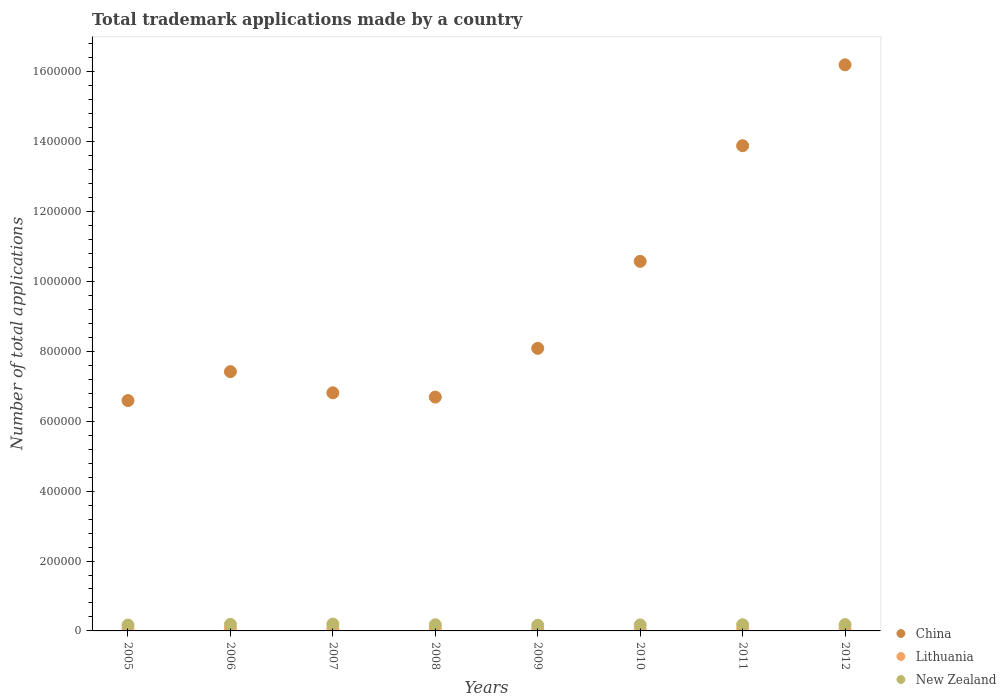How many different coloured dotlines are there?
Keep it short and to the point. 3. Is the number of dotlines equal to the number of legend labels?
Offer a very short reply. Yes. What is the number of applications made by in China in 2009?
Provide a succinct answer. 8.09e+05. Across all years, what is the maximum number of applications made by in New Zealand?
Give a very brief answer. 1.96e+04. Across all years, what is the minimum number of applications made by in New Zealand?
Offer a very short reply. 1.62e+04. In which year was the number of applications made by in Lithuania maximum?
Offer a terse response. 2007. In which year was the number of applications made by in China minimum?
Offer a terse response. 2005. What is the total number of applications made by in China in the graph?
Give a very brief answer. 7.63e+06. What is the difference between the number of applications made by in New Zealand in 2011 and that in 2012?
Give a very brief answer. -279. What is the difference between the number of applications made by in Lithuania in 2006 and the number of applications made by in China in 2010?
Your response must be concise. -1.05e+06. What is the average number of applications made by in China per year?
Your answer should be very brief. 9.53e+05. In the year 2006, what is the difference between the number of applications made by in China and number of applications made by in New Zealand?
Offer a terse response. 7.23e+05. In how many years, is the number of applications made by in Lithuania greater than 280000?
Give a very brief answer. 0. What is the ratio of the number of applications made by in China in 2005 to that in 2007?
Provide a succinct answer. 0.97. Is the difference between the number of applications made by in China in 2006 and 2007 greater than the difference between the number of applications made by in New Zealand in 2006 and 2007?
Your answer should be compact. Yes. What is the difference between the highest and the second highest number of applications made by in New Zealand?
Ensure brevity in your answer.  784. What is the difference between the highest and the lowest number of applications made by in New Zealand?
Ensure brevity in your answer.  3420. Is the sum of the number of applications made by in China in 2009 and 2010 greater than the maximum number of applications made by in Lithuania across all years?
Ensure brevity in your answer.  Yes. Is it the case that in every year, the sum of the number of applications made by in New Zealand and number of applications made by in Lithuania  is greater than the number of applications made by in China?
Offer a very short reply. No. What is the difference between two consecutive major ticks on the Y-axis?
Your answer should be compact. 2.00e+05. Are the values on the major ticks of Y-axis written in scientific E-notation?
Provide a succinct answer. No. Does the graph contain any zero values?
Your response must be concise. No. How are the legend labels stacked?
Provide a succinct answer. Vertical. What is the title of the graph?
Provide a short and direct response. Total trademark applications made by a country. Does "Tunisia" appear as one of the legend labels in the graph?
Offer a very short reply. No. What is the label or title of the Y-axis?
Provide a succinct answer. Number of total applications. What is the Number of total applications of China in 2005?
Your answer should be compact. 6.59e+05. What is the Number of total applications in Lithuania in 2005?
Provide a short and direct response. 6302. What is the Number of total applications of New Zealand in 2005?
Offer a terse response. 1.68e+04. What is the Number of total applications of China in 2006?
Provide a short and direct response. 7.42e+05. What is the Number of total applications of Lithuania in 2006?
Offer a very short reply. 6369. What is the Number of total applications in New Zealand in 2006?
Ensure brevity in your answer.  1.88e+04. What is the Number of total applications in China in 2007?
Ensure brevity in your answer.  6.81e+05. What is the Number of total applications in Lithuania in 2007?
Your answer should be very brief. 6440. What is the Number of total applications in New Zealand in 2007?
Offer a very short reply. 1.96e+04. What is the Number of total applications of China in 2008?
Your answer should be very brief. 6.69e+05. What is the Number of total applications in Lithuania in 2008?
Your response must be concise. 6332. What is the Number of total applications in New Zealand in 2008?
Make the answer very short. 1.76e+04. What is the Number of total applications of China in 2009?
Your answer should be very brief. 8.09e+05. What is the Number of total applications of Lithuania in 2009?
Keep it short and to the point. 4465. What is the Number of total applications of New Zealand in 2009?
Ensure brevity in your answer.  1.62e+04. What is the Number of total applications of China in 2010?
Your answer should be compact. 1.06e+06. What is the Number of total applications of Lithuania in 2010?
Your response must be concise. 4274. What is the Number of total applications in New Zealand in 2010?
Your answer should be compact. 1.71e+04. What is the Number of total applications in China in 2011?
Provide a short and direct response. 1.39e+06. What is the Number of total applications of Lithuania in 2011?
Give a very brief answer. 4315. What is the Number of total applications of New Zealand in 2011?
Ensure brevity in your answer.  1.77e+04. What is the Number of total applications of China in 2012?
Provide a short and direct response. 1.62e+06. What is the Number of total applications in Lithuania in 2012?
Your response must be concise. 4222. What is the Number of total applications of New Zealand in 2012?
Your response must be concise. 1.80e+04. Across all years, what is the maximum Number of total applications of China?
Offer a terse response. 1.62e+06. Across all years, what is the maximum Number of total applications of Lithuania?
Offer a terse response. 6440. Across all years, what is the maximum Number of total applications in New Zealand?
Keep it short and to the point. 1.96e+04. Across all years, what is the minimum Number of total applications of China?
Ensure brevity in your answer.  6.59e+05. Across all years, what is the minimum Number of total applications of Lithuania?
Your answer should be very brief. 4222. Across all years, what is the minimum Number of total applications in New Zealand?
Provide a short and direct response. 1.62e+04. What is the total Number of total applications in China in the graph?
Ensure brevity in your answer.  7.63e+06. What is the total Number of total applications of Lithuania in the graph?
Your response must be concise. 4.27e+04. What is the total Number of total applications of New Zealand in the graph?
Ensure brevity in your answer.  1.42e+05. What is the difference between the Number of total applications of China in 2005 and that in 2006?
Give a very brief answer. -8.28e+04. What is the difference between the Number of total applications of Lithuania in 2005 and that in 2006?
Your answer should be very brief. -67. What is the difference between the Number of total applications of New Zealand in 2005 and that in 2006?
Your answer should be very brief. -1993. What is the difference between the Number of total applications of China in 2005 and that in 2007?
Provide a succinct answer. -2.22e+04. What is the difference between the Number of total applications in Lithuania in 2005 and that in 2007?
Your response must be concise. -138. What is the difference between the Number of total applications in New Zealand in 2005 and that in 2007?
Your response must be concise. -2777. What is the difference between the Number of total applications of China in 2005 and that in 2008?
Offer a terse response. -9940. What is the difference between the Number of total applications of Lithuania in 2005 and that in 2008?
Make the answer very short. -30. What is the difference between the Number of total applications in New Zealand in 2005 and that in 2008?
Ensure brevity in your answer.  -749. What is the difference between the Number of total applications of China in 2005 and that in 2009?
Give a very brief answer. -1.49e+05. What is the difference between the Number of total applications of Lithuania in 2005 and that in 2009?
Provide a short and direct response. 1837. What is the difference between the Number of total applications of New Zealand in 2005 and that in 2009?
Make the answer very short. 643. What is the difference between the Number of total applications of China in 2005 and that in 2010?
Give a very brief answer. -3.98e+05. What is the difference between the Number of total applications in Lithuania in 2005 and that in 2010?
Your answer should be very brief. 2028. What is the difference between the Number of total applications of New Zealand in 2005 and that in 2010?
Ensure brevity in your answer.  -291. What is the difference between the Number of total applications of China in 2005 and that in 2011?
Give a very brief answer. -7.29e+05. What is the difference between the Number of total applications of Lithuania in 2005 and that in 2011?
Your answer should be very brief. 1987. What is the difference between the Number of total applications in New Zealand in 2005 and that in 2011?
Your answer should be very brief. -915. What is the difference between the Number of total applications in China in 2005 and that in 2012?
Keep it short and to the point. -9.61e+05. What is the difference between the Number of total applications in Lithuania in 2005 and that in 2012?
Your answer should be compact. 2080. What is the difference between the Number of total applications of New Zealand in 2005 and that in 2012?
Make the answer very short. -1194. What is the difference between the Number of total applications of China in 2006 and that in 2007?
Your answer should be compact. 6.06e+04. What is the difference between the Number of total applications in Lithuania in 2006 and that in 2007?
Your answer should be very brief. -71. What is the difference between the Number of total applications in New Zealand in 2006 and that in 2007?
Provide a short and direct response. -784. What is the difference between the Number of total applications in China in 2006 and that in 2008?
Offer a very short reply. 7.29e+04. What is the difference between the Number of total applications in Lithuania in 2006 and that in 2008?
Provide a short and direct response. 37. What is the difference between the Number of total applications of New Zealand in 2006 and that in 2008?
Give a very brief answer. 1244. What is the difference between the Number of total applications in China in 2006 and that in 2009?
Give a very brief answer. -6.66e+04. What is the difference between the Number of total applications in Lithuania in 2006 and that in 2009?
Keep it short and to the point. 1904. What is the difference between the Number of total applications in New Zealand in 2006 and that in 2009?
Keep it short and to the point. 2636. What is the difference between the Number of total applications in China in 2006 and that in 2010?
Provide a short and direct response. -3.16e+05. What is the difference between the Number of total applications of Lithuania in 2006 and that in 2010?
Your response must be concise. 2095. What is the difference between the Number of total applications in New Zealand in 2006 and that in 2010?
Ensure brevity in your answer.  1702. What is the difference between the Number of total applications in China in 2006 and that in 2011?
Keep it short and to the point. -6.46e+05. What is the difference between the Number of total applications in Lithuania in 2006 and that in 2011?
Give a very brief answer. 2054. What is the difference between the Number of total applications of New Zealand in 2006 and that in 2011?
Ensure brevity in your answer.  1078. What is the difference between the Number of total applications in China in 2006 and that in 2012?
Make the answer very short. -8.78e+05. What is the difference between the Number of total applications in Lithuania in 2006 and that in 2012?
Provide a succinct answer. 2147. What is the difference between the Number of total applications of New Zealand in 2006 and that in 2012?
Offer a very short reply. 799. What is the difference between the Number of total applications in China in 2007 and that in 2008?
Give a very brief answer. 1.23e+04. What is the difference between the Number of total applications of Lithuania in 2007 and that in 2008?
Your response must be concise. 108. What is the difference between the Number of total applications in New Zealand in 2007 and that in 2008?
Provide a succinct answer. 2028. What is the difference between the Number of total applications in China in 2007 and that in 2009?
Your answer should be very brief. -1.27e+05. What is the difference between the Number of total applications in Lithuania in 2007 and that in 2009?
Your response must be concise. 1975. What is the difference between the Number of total applications of New Zealand in 2007 and that in 2009?
Provide a short and direct response. 3420. What is the difference between the Number of total applications of China in 2007 and that in 2010?
Your answer should be compact. -3.76e+05. What is the difference between the Number of total applications of Lithuania in 2007 and that in 2010?
Your answer should be very brief. 2166. What is the difference between the Number of total applications in New Zealand in 2007 and that in 2010?
Your response must be concise. 2486. What is the difference between the Number of total applications in China in 2007 and that in 2011?
Provide a succinct answer. -7.07e+05. What is the difference between the Number of total applications in Lithuania in 2007 and that in 2011?
Your answer should be compact. 2125. What is the difference between the Number of total applications in New Zealand in 2007 and that in 2011?
Make the answer very short. 1862. What is the difference between the Number of total applications in China in 2007 and that in 2012?
Offer a very short reply. -9.39e+05. What is the difference between the Number of total applications in Lithuania in 2007 and that in 2012?
Your answer should be compact. 2218. What is the difference between the Number of total applications in New Zealand in 2007 and that in 2012?
Offer a terse response. 1583. What is the difference between the Number of total applications of China in 2008 and that in 2009?
Make the answer very short. -1.39e+05. What is the difference between the Number of total applications in Lithuania in 2008 and that in 2009?
Your answer should be very brief. 1867. What is the difference between the Number of total applications in New Zealand in 2008 and that in 2009?
Ensure brevity in your answer.  1392. What is the difference between the Number of total applications of China in 2008 and that in 2010?
Offer a terse response. -3.88e+05. What is the difference between the Number of total applications of Lithuania in 2008 and that in 2010?
Offer a very short reply. 2058. What is the difference between the Number of total applications of New Zealand in 2008 and that in 2010?
Provide a succinct answer. 458. What is the difference between the Number of total applications in China in 2008 and that in 2011?
Your answer should be very brief. -7.19e+05. What is the difference between the Number of total applications in Lithuania in 2008 and that in 2011?
Give a very brief answer. 2017. What is the difference between the Number of total applications in New Zealand in 2008 and that in 2011?
Ensure brevity in your answer.  -166. What is the difference between the Number of total applications in China in 2008 and that in 2012?
Give a very brief answer. -9.51e+05. What is the difference between the Number of total applications of Lithuania in 2008 and that in 2012?
Ensure brevity in your answer.  2110. What is the difference between the Number of total applications in New Zealand in 2008 and that in 2012?
Your answer should be very brief. -445. What is the difference between the Number of total applications of China in 2009 and that in 2010?
Your answer should be compact. -2.49e+05. What is the difference between the Number of total applications in Lithuania in 2009 and that in 2010?
Your response must be concise. 191. What is the difference between the Number of total applications in New Zealand in 2009 and that in 2010?
Your answer should be compact. -934. What is the difference between the Number of total applications of China in 2009 and that in 2011?
Your answer should be compact. -5.80e+05. What is the difference between the Number of total applications in Lithuania in 2009 and that in 2011?
Your answer should be very brief. 150. What is the difference between the Number of total applications in New Zealand in 2009 and that in 2011?
Give a very brief answer. -1558. What is the difference between the Number of total applications in China in 2009 and that in 2012?
Make the answer very short. -8.11e+05. What is the difference between the Number of total applications in Lithuania in 2009 and that in 2012?
Offer a terse response. 243. What is the difference between the Number of total applications of New Zealand in 2009 and that in 2012?
Your answer should be very brief. -1837. What is the difference between the Number of total applications in China in 2010 and that in 2011?
Your answer should be very brief. -3.31e+05. What is the difference between the Number of total applications of Lithuania in 2010 and that in 2011?
Your response must be concise. -41. What is the difference between the Number of total applications of New Zealand in 2010 and that in 2011?
Provide a short and direct response. -624. What is the difference between the Number of total applications of China in 2010 and that in 2012?
Your answer should be very brief. -5.62e+05. What is the difference between the Number of total applications in New Zealand in 2010 and that in 2012?
Your answer should be very brief. -903. What is the difference between the Number of total applications in China in 2011 and that in 2012?
Keep it short and to the point. -2.31e+05. What is the difference between the Number of total applications in Lithuania in 2011 and that in 2012?
Make the answer very short. 93. What is the difference between the Number of total applications in New Zealand in 2011 and that in 2012?
Ensure brevity in your answer.  -279. What is the difference between the Number of total applications in China in 2005 and the Number of total applications in Lithuania in 2006?
Your response must be concise. 6.53e+05. What is the difference between the Number of total applications in China in 2005 and the Number of total applications in New Zealand in 2006?
Your answer should be compact. 6.40e+05. What is the difference between the Number of total applications in Lithuania in 2005 and the Number of total applications in New Zealand in 2006?
Offer a terse response. -1.25e+04. What is the difference between the Number of total applications in China in 2005 and the Number of total applications in Lithuania in 2007?
Make the answer very short. 6.53e+05. What is the difference between the Number of total applications in China in 2005 and the Number of total applications in New Zealand in 2007?
Your answer should be compact. 6.40e+05. What is the difference between the Number of total applications in Lithuania in 2005 and the Number of total applications in New Zealand in 2007?
Give a very brief answer. -1.33e+04. What is the difference between the Number of total applications of China in 2005 and the Number of total applications of Lithuania in 2008?
Provide a succinct answer. 6.53e+05. What is the difference between the Number of total applications of China in 2005 and the Number of total applications of New Zealand in 2008?
Offer a terse response. 6.42e+05. What is the difference between the Number of total applications of Lithuania in 2005 and the Number of total applications of New Zealand in 2008?
Provide a succinct answer. -1.13e+04. What is the difference between the Number of total applications of China in 2005 and the Number of total applications of Lithuania in 2009?
Make the answer very short. 6.55e+05. What is the difference between the Number of total applications of China in 2005 and the Number of total applications of New Zealand in 2009?
Your answer should be compact. 6.43e+05. What is the difference between the Number of total applications of Lithuania in 2005 and the Number of total applications of New Zealand in 2009?
Your answer should be very brief. -9888. What is the difference between the Number of total applications in China in 2005 and the Number of total applications in Lithuania in 2010?
Keep it short and to the point. 6.55e+05. What is the difference between the Number of total applications of China in 2005 and the Number of total applications of New Zealand in 2010?
Ensure brevity in your answer.  6.42e+05. What is the difference between the Number of total applications in Lithuania in 2005 and the Number of total applications in New Zealand in 2010?
Your response must be concise. -1.08e+04. What is the difference between the Number of total applications of China in 2005 and the Number of total applications of Lithuania in 2011?
Provide a short and direct response. 6.55e+05. What is the difference between the Number of total applications in China in 2005 and the Number of total applications in New Zealand in 2011?
Give a very brief answer. 6.41e+05. What is the difference between the Number of total applications in Lithuania in 2005 and the Number of total applications in New Zealand in 2011?
Provide a succinct answer. -1.14e+04. What is the difference between the Number of total applications in China in 2005 and the Number of total applications in Lithuania in 2012?
Offer a terse response. 6.55e+05. What is the difference between the Number of total applications in China in 2005 and the Number of total applications in New Zealand in 2012?
Your answer should be very brief. 6.41e+05. What is the difference between the Number of total applications in Lithuania in 2005 and the Number of total applications in New Zealand in 2012?
Your answer should be compact. -1.17e+04. What is the difference between the Number of total applications of China in 2006 and the Number of total applications of Lithuania in 2007?
Make the answer very short. 7.36e+05. What is the difference between the Number of total applications in China in 2006 and the Number of total applications in New Zealand in 2007?
Make the answer very short. 7.22e+05. What is the difference between the Number of total applications of Lithuania in 2006 and the Number of total applications of New Zealand in 2007?
Your response must be concise. -1.32e+04. What is the difference between the Number of total applications of China in 2006 and the Number of total applications of Lithuania in 2008?
Provide a succinct answer. 7.36e+05. What is the difference between the Number of total applications in China in 2006 and the Number of total applications in New Zealand in 2008?
Keep it short and to the point. 7.24e+05. What is the difference between the Number of total applications of Lithuania in 2006 and the Number of total applications of New Zealand in 2008?
Ensure brevity in your answer.  -1.12e+04. What is the difference between the Number of total applications of China in 2006 and the Number of total applications of Lithuania in 2009?
Provide a short and direct response. 7.37e+05. What is the difference between the Number of total applications in China in 2006 and the Number of total applications in New Zealand in 2009?
Keep it short and to the point. 7.26e+05. What is the difference between the Number of total applications in Lithuania in 2006 and the Number of total applications in New Zealand in 2009?
Offer a very short reply. -9821. What is the difference between the Number of total applications of China in 2006 and the Number of total applications of Lithuania in 2010?
Make the answer very short. 7.38e+05. What is the difference between the Number of total applications in China in 2006 and the Number of total applications in New Zealand in 2010?
Offer a very short reply. 7.25e+05. What is the difference between the Number of total applications of Lithuania in 2006 and the Number of total applications of New Zealand in 2010?
Offer a terse response. -1.08e+04. What is the difference between the Number of total applications of China in 2006 and the Number of total applications of Lithuania in 2011?
Offer a very short reply. 7.38e+05. What is the difference between the Number of total applications of China in 2006 and the Number of total applications of New Zealand in 2011?
Your answer should be very brief. 7.24e+05. What is the difference between the Number of total applications in Lithuania in 2006 and the Number of total applications in New Zealand in 2011?
Offer a terse response. -1.14e+04. What is the difference between the Number of total applications in China in 2006 and the Number of total applications in Lithuania in 2012?
Your response must be concise. 7.38e+05. What is the difference between the Number of total applications in China in 2006 and the Number of total applications in New Zealand in 2012?
Your answer should be compact. 7.24e+05. What is the difference between the Number of total applications of Lithuania in 2006 and the Number of total applications of New Zealand in 2012?
Your answer should be very brief. -1.17e+04. What is the difference between the Number of total applications of China in 2007 and the Number of total applications of Lithuania in 2008?
Offer a terse response. 6.75e+05. What is the difference between the Number of total applications in China in 2007 and the Number of total applications in New Zealand in 2008?
Keep it short and to the point. 6.64e+05. What is the difference between the Number of total applications in Lithuania in 2007 and the Number of total applications in New Zealand in 2008?
Offer a very short reply. -1.11e+04. What is the difference between the Number of total applications of China in 2007 and the Number of total applications of Lithuania in 2009?
Keep it short and to the point. 6.77e+05. What is the difference between the Number of total applications in China in 2007 and the Number of total applications in New Zealand in 2009?
Make the answer very short. 6.65e+05. What is the difference between the Number of total applications of Lithuania in 2007 and the Number of total applications of New Zealand in 2009?
Your answer should be very brief. -9750. What is the difference between the Number of total applications of China in 2007 and the Number of total applications of Lithuania in 2010?
Your answer should be compact. 6.77e+05. What is the difference between the Number of total applications of China in 2007 and the Number of total applications of New Zealand in 2010?
Ensure brevity in your answer.  6.64e+05. What is the difference between the Number of total applications of Lithuania in 2007 and the Number of total applications of New Zealand in 2010?
Provide a short and direct response. -1.07e+04. What is the difference between the Number of total applications of China in 2007 and the Number of total applications of Lithuania in 2011?
Your response must be concise. 6.77e+05. What is the difference between the Number of total applications of China in 2007 and the Number of total applications of New Zealand in 2011?
Your answer should be very brief. 6.64e+05. What is the difference between the Number of total applications of Lithuania in 2007 and the Number of total applications of New Zealand in 2011?
Keep it short and to the point. -1.13e+04. What is the difference between the Number of total applications of China in 2007 and the Number of total applications of Lithuania in 2012?
Your answer should be very brief. 6.77e+05. What is the difference between the Number of total applications of China in 2007 and the Number of total applications of New Zealand in 2012?
Your response must be concise. 6.63e+05. What is the difference between the Number of total applications in Lithuania in 2007 and the Number of total applications in New Zealand in 2012?
Give a very brief answer. -1.16e+04. What is the difference between the Number of total applications of China in 2008 and the Number of total applications of Lithuania in 2009?
Keep it short and to the point. 6.65e+05. What is the difference between the Number of total applications of China in 2008 and the Number of total applications of New Zealand in 2009?
Provide a short and direct response. 6.53e+05. What is the difference between the Number of total applications in Lithuania in 2008 and the Number of total applications in New Zealand in 2009?
Your answer should be compact. -9858. What is the difference between the Number of total applications of China in 2008 and the Number of total applications of Lithuania in 2010?
Provide a short and direct response. 6.65e+05. What is the difference between the Number of total applications in China in 2008 and the Number of total applications in New Zealand in 2010?
Ensure brevity in your answer.  6.52e+05. What is the difference between the Number of total applications of Lithuania in 2008 and the Number of total applications of New Zealand in 2010?
Make the answer very short. -1.08e+04. What is the difference between the Number of total applications in China in 2008 and the Number of total applications in Lithuania in 2011?
Your answer should be very brief. 6.65e+05. What is the difference between the Number of total applications in China in 2008 and the Number of total applications in New Zealand in 2011?
Your answer should be very brief. 6.51e+05. What is the difference between the Number of total applications in Lithuania in 2008 and the Number of total applications in New Zealand in 2011?
Keep it short and to the point. -1.14e+04. What is the difference between the Number of total applications of China in 2008 and the Number of total applications of Lithuania in 2012?
Keep it short and to the point. 6.65e+05. What is the difference between the Number of total applications in China in 2008 and the Number of total applications in New Zealand in 2012?
Keep it short and to the point. 6.51e+05. What is the difference between the Number of total applications of Lithuania in 2008 and the Number of total applications of New Zealand in 2012?
Ensure brevity in your answer.  -1.17e+04. What is the difference between the Number of total applications of China in 2009 and the Number of total applications of Lithuania in 2010?
Make the answer very short. 8.04e+05. What is the difference between the Number of total applications in China in 2009 and the Number of total applications in New Zealand in 2010?
Give a very brief answer. 7.91e+05. What is the difference between the Number of total applications in Lithuania in 2009 and the Number of total applications in New Zealand in 2010?
Give a very brief answer. -1.27e+04. What is the difference between the Number of total applications in China in 2009 and the Number of total applications in Lithuania in 2011?
Your answer should be very brief. 8.04e+05. What is the difference between the Number of total applications in China in 2009 and the Number of total applications in New Zealand in 2011?
Offer a terse response. 7.91e+05. What is the difference between the Number of total applications in Lithuania in 2009 and the Number of total applications in New Zealand in 2011?
Your answer should be very brief. -1.33e+04. What is the difference between the Number of total applications in China in 2009 and the Number of total applications in Lithuania in 2012?
Your response must be concise. 8.04e+05. What is the difference between the Number of total applications in China in 2009 and the Number of total applications in New Zealand in 2012?
Keep it short and to the point. 7.91e+05. What is the difference between the Number of total applications in Lithuania in 2009 and the Number of total applications in New Zealand in 2012?
Give a very brief answer. -1.36e+04. What is the difference between the Number of total applications in China in 2010 and the Number of total applications in Lithuania in 2011?
Your answer should be very brief. 1.05e+06. What is the difference between the Number of total applications of China in 2010 and the Number of total applications of New Zealand in 2011?
Make the answer very short. 1.04e+06. What is the difference between the Number of total applications in Lithuania in 2010 and the Number of total applications in New Zealand in 2011?
Offer a terse response. -1.35e+04. What is the difference between the Number of total applications in China in 2010 and the Number of total applications in Lithuania in 2012?
Offer a terse response. 1.05e+06. What is the difference between the Number of total applications of China in 2010 and the Number of total applications of New Zealand in 2012?
Ensure brevity in your answer.  1.04e+06. What is the difference between the Number of total applications of Lithuania in 2010 and the Number of total applications of New Zealand in 2012?
Give a very brief answer. -1.38e+04. What is the difference between the Number of total applications in China in 2011 and the Number of total applications in Lithuania in 2012?
Offer a terse response. 1.38e+06. What is the difference between the Number of total applications of China in 2011 and the Number of total applications of New Zealand in 2012?
Keep it short and to the point. 1.37e+06. What is the difference between the Number of total applications of Lithuania in 2011 and the Number of total applications of New Zealand in 2012?
Your answer should be compact. -1.37e+04. What is the average Number of total applications in China per year?
Provide a succinct answer. 9.53e+05. What is the average Number of total applications of Lithuania per year?
Your answer should be very brief. 5339.88. What is the average Number of total applications of New Zealand per year?
Make the answer very short. 1.77e+04. In the year 2005, what is the difference between the Number of total applications of China and Number of total applications of Lithuania?
Your answer should be compact. 6.53e+05. In the year 2005, what is the difference between the Number of total applications in China and Number of total applications in New Zealand?
Keep it short and to the point. 6.42e+05. In the year 2005, what is the difference between the Number of total applications in Lithuania and Number of total applications in New Zealand?
Your answer should be compact. -1.05e+04. In the year 2006, what is the difference between the Number of total applications in China and Number of total applications in Lithuania?
Provide a succinct answer. 7.36e+05. In the year 2006, what is the difference between the Number of total applications in China and Number of total applications in New Zealand?
Give a very brief answer. 7.23e+05. In the year 2006, what is the difference between the Number of total applications in Lithuania and Number of total applications in New Zealand?
Ensure brevity in your answer.  -1.25e+04. In the year 2007, what is the difference between the Number of total applications of China and Number of total applications of Lithuania?
Provide a short and direct response. 6.75e+05. In the year 2007, what is the difference between the Number of total applications in China and Number of total applications in New Zealand?
Offer a very short reply. 6.62e+05. In the year 2007, what is the difference between the Number of total applications of Lithuania and Number of total applications of New Zealand?
Provide a short and direct response. -1.32e+04. In the year 2008, what is the difference between the Number of total applications of China and Number of total applications of Lithuania?
Your response must be concise. 6.63e+05. In the year 2008, what is the difference between the Number of total applications of China and Number of total applications of New Zealand?
Ensure brevity in your answer.  6.52e+05. In the year 2008, what is the difference between the Number of total applications of Lithuania and Number of total applications of New Zealand?
Make the answer very short. -1.12e+04. In the year 2009, what is the difference between the Number of total applications of China and Number of total applications of Lithuania?
Provide a short and direct response. 8.04e+05. In the year 2009, what is the difference between the Number of total applications in China and Number of total applications in New Zealand?
Make the answer very short. 7.92e+05. In the year 2009, what is the difference between the Number of total applications in Lithuania and Number of total applications in New Zealand?
Your response must be concise. -1.17e+04. In the year 2010, what is the difference between the Number of total applications in China and Number of total applications in Lithuania?
Your answer should be very brief. 1.05e+06. In the year 2010, what is the difference between the Number of total applications of China and Number of total applications of New Zealand?
Your answer should be compact. 1.04e+06. In the year 2010, what is the difference between the Number of total applications of Lithuania and Number of total applications of New Zealand?
Ensure brevity in your answer.  -1.28e+04. In the year 2011, what is the difference between the Number of total applications of China and Number of total applications of Lithuania?
Keep it short and to the point. 1.38e+06. In the year 2011, what is the difference between the Number of total applications of China and Number of total applications of New Zealand?
Ensure brevity in your answer.  1.37e+06. In the year 2011, what is the difference between the Number of total applications in Lithuania and Number of total applications in New Zealand?
Make the answer very short. -1.34e+04. In the year 2012, what is the difference between the Number of total applications of China and Number of total applications of Lithuania?
Offer a very short reply. 1.62e+06. In the year 2012, what is the difference between the Number of total applications in China and Number of total applications in New Zealand?
Your answer should be compact. 1.60e+06. In the year 2012, what is the difference between the Number of total applications in Lithuania and Number of total applications in New Zealand?
Provide a succinct answer. -1.38e+04. What is the ratio of the Number of total applications in China in 2005 to that in 2006?
Make the answer very short. 0.89. What is the ratio of the Number of total applications in Lithuania in 2005 to that in 2006?
Offer a very short reply. 0.99. What is the ratio of the Number of total applications of New Zealand in 2005 to that in 2006?
Keep it short and to the point. 0.89. What is the ratio of the Number of total applications in China in 2005 to that in 2007?
Ensure brevity in your answer.  0.97. What is the ratio of the Number of total applications of Lithuania in 2005 to that in 2007?
Offer a terse response. 0.98. What is the ratio of the Number of total applications in New Zealand in 2005 to that in 2007?
Give a very brief answer. 0.86. What is the ratio of the Number of total applications in China in 2005 to that in 2008?
Ensure brevity in your answer.  0.99. What is the ratio of the Number of total applications in Lithuania in 2005 to that in 2008?
Offer a terse response. 1. What is the ratio of the Number of total applications in New Zealand in 2005 to that in 2008?
Your answer should be compact. 0.96. What is the ratio of the Number of total applications of China in 2005 to that in 2009?
Offer a terse response. 0.82. What is the ratio of the Number of total applications in Lithuania in 2005 to that in 2009?
Your answer should be very brief. 1.41. What is the ratio of the Number of total applications in New Zealand in 2005 to that in 2009?
Ensure brevity in your answer.  1.04. What is the ratio of the Number of total applications of China in 2005 to that in 2010?
Offer a terse response. 0.62. What is the ratio of the Number of total applications of Lithuania in 2005 to that in 2010?
Keep it short and to the point. 1.47. What is the ratio of the Number of total applications of New Zealand in 2005 to that in 2010?
Your response must be concise. 0.98. What is the ratio of the Number of total applications of China in 2005 to that in 2011?
Ensure brevity in your answer.  0.47. What is the ratio of the Number of total applications in Lithuania in 2005 to that in 2011?
Ensure brevity in your answer.  1.46. What is the ratio of the Number of total applications of New Zealand in 2005 to that in 2011?
Offer a terse response. 0.95. What is the ratio of the Number of total applications in China in 2005 to that in 2012?
Give a very brief answer. 0.41. What is the ratio of the Number of total applications in Lithuania in 2005 to that in 2012?
Your response must be concise. 1.49. What is the ratio of the Number of total applications in New Zealand in 2005 to that in 2012?
Offer a very short reply. 0.93. What is the ratio of the Number of total applications in China in 2006 to that in 2007?
Give a very brief answer. 1.09. What is the ratio of the Number of total applications in Lithuania in 2006 to that in 2007?
Keep it short and to the point. 0.99. What is the ratio of the Number of total applications in China in 2006 to that in 2008?
Give a very brief answer. 1.11. What is the ratio of the Number of total applications of Lithuania in 2006 to that in 2008?
Ensure brevity in your answer.  1.01. What is the ratio of the Number of total applications in New Zealand in 2006 to that in 2008?
Make the answer very short. 1.07. What is the ratio of the Number of total applications in China in 2006 to that in 2009?
Your response must be concise. 0.92. What is the ratio of the Number of total applications in Lithuania in 2006 to that in 2009?
Keep it short and to the point. 1.43. What is the ratio of the Number of total applications in New Zealand in 2006 to that in 2009?
Your answer should be very brief. 1.16. What is the ratio of the Number of total applications of China in 2006 to that in 2010?
Your response must be concise. 0.7. What is the ratio of the Number of total applications in Lithuania in 2006 to that in 2010?
Your response must be concise. 1.49. What is the ratio of the Number of total applications of New Zealand in 2006 to that in 2010?
Give a very brief answer. 1.1. What is the ratio of the Number of total applications of China in 2006 to that in 2011?
Offer a very short reply. 0.53. What is the ratio of the Number of total applications of Lithuania in 2006 to that in 2011?
Give a very brief answer. 1.48. What is the ratio of the Number of total applications of New Zealand in 2006 to that in 2011?
Your answer should be very brief. 1.06. What is the ratio of the Number of total applications of China in 2006 to that in 2012?
Make the answer very short. 0.46. What is the ratio of the Number of total applications of Lithuania in 2006 to that in 2012?
Provide a short and direct response. 1.51. What is the ratio of the Number of total applications in New Zealand in 2006 to that in 2012?
Ensure brevity in your answer.  1.04. What is the ratio of the Number of total applications in China in 2007 to that in 2008?
Give a very brief answer. 1.02. What is the ratio of the Number of total applications of Lithuania in 2007 to that in 2008?
Your answer should be very brief. 1.02. What is the ratio of the Number of total applications in New Zealand in 2007 to that in 2008?
Offer a terse response. 1.12. What is the ratio of the Number of total applications in China in 2007 to that in 2009?
Keep it short and to the point. 0.84. What is the ratio of the Number of total applications in Lithuania in 2007 to that in 2009?
Offer a very short reply. 1.44. What is the ratio of the Number of total applications in New Zealand in 2007 to that in 2009?
Your response must be concise. 1.21. What is the ratio of the Number of total applications in China in 2007 to that in 2010?
Provide a short and direct response. 0.64. What is the ratio of the Number of total applications in Lithuania in 2007 to that in 2010?
Your response must be concise. 1.51. What is the ratio of the Number of total applications of New Zealand in 2007 to that in 2010?
Give a very brief answer. 1.15. What is the ratio of the Number of total applications of China in 2007 to that in 2011?
Give a very brief answer. 0.49. What is the ratio of the Number of total applications in Lithuania in 2007 to that in 2011?
Keep it short and to the point. 1.49. What is the ratio of the Number of total applications in New Zealand in 2007 to that in 2011?
Your response must be concise. 1.1. What is the ratio of the Number of total applications of China in 2007 to that in 2012?
Make the answer very short. 0.42. What is the ratio of the Number of total applications in Lithuania in 2007 to that in 2012?
Give a very brief answer. 1.53. What is the ratio of the Number of total applications in New Zealand in 2007 to that in 2012?
Provide a short and direct response. 1.09. What is the ratio of the Number of total applications of China in 2008 to that in 2009?
Make the answer very short. 0.83. What is the ratio of the Number of total applications in Lithuania in 2008 to that in 2009?
Make the answer very short. 1.42. What is the ratio of the Number of total applications in New Zealand in 2008 to that in 2009?
Provide a short and direct response. 1.09. What is the ratio of the Number of total applications in China in 2008 to that in 2010?
Give a very brief answer. 0.63. What is the ratio of the Number of total applications of Lithuania in 2008 to that in 2010?
Make the answer very short. 1.48. What is the ratio of the Number of total applications of New Zealand in 2008 to that in 2010?
Your response must be concise. 1.03. What is the ratio of the Number of total applications of China in 2008 to that in 2011?
Keep it short and to the point. 0.48. What is the ratio of the Number of total applications in Lithuania in 2008 to that in 2011?
Offer a terse response. 1.47. What is the ratio of the Number of total applications of New Zealand in 2008 to that in 2011?
Ensure brevity in your answer.  0.99. What is the ratio of the Number of total applications in China in 2008 to that in 2012?
Your response must be concise. 0.41. What is the ratio of the Number of total applications in Lithuania in 2008 to that in 2012?
Your answer should be compact. 1.5. What is the ratio of the Number of total applications of New Zealand in 2008 to that in 2012?
Your response must be concise. 0.98. What is the ratio of the Number of total applications of China in 2009 to that in 2010?
Your response must be concise. 0.76. What is the ratio of the Number of total applications of Lithuania in 2009 to that in 2010?
Make the answer very short. 1.04. What is the ratio of the Number of total applications in New Zealand in 2009 to that in 2010?
Give a very brief answer. 0.95. What is the ratio of the Number of total applications in China in 2009 to that in 2011?
Make the answer very short. 0.58. What is the ratio of the Number of total applications of Lithuania in 2009 to that in 2011?
Your response must be concise. 1.03. What is the ratio of the Number of total applications in New Zealand in 2009 to that in 2011?
Provide a short and direct response. 0.91. What is the ratio of the Number of total applications of China in 2009 to that in 2012?
Make the answer very short. 0.5. What is the ratio of the Number of total applications of Lithuania in 2009 to that in 2012?
Provide a short and direct response. 1.06. What is the ratio of the Number of total applications in New Zealand in 2009 to that in 2012?
Your answer should be compact. 0.9. What is the ratio of the Number of total applications in China in 2010 to that in 2011?
Provide a short and direct response. 0.76. What is the ratio of the Number of total applications of Lithuania in 2010 to that in 2011?
Keep it short and to the point. 0.99. What is the ratio of the Number of total applications in New Zealand in 2010 to that in 2011?
Your response must be concise. 0.96. What is the ratio of the Number of total applications of China in 2010 to that in 2012?
Offer a very short reply. 0.65. What is the ratio of the Number of total applications in Lithuania in 2010 to that in 2012?
Your answer should be compact. 1.01. What is the ratio of the Number of total applications in New Zealand in 2010 to that in 2012?
Keep it short and to the point. 0.95. What is the ratio of the Number of total applications in Lithuania in 2011 to that in 2012?
Your response must be concise. 1.02. What is the ratio of the Number of total applications in New Zealand in 2011 to that in 2012?
Your response must be concise. 0.98. What is the difference between the highest and the second highest Number of total applications in China?
Offer a terse response. 2.31e+05. What is the difference between the highest and the second highest Number of total applications in Lithuania?
Keep it short and to the point. 71. What is the difference between the highest and the second highest Number of total applications in New Zealand?
Keep it short and to the point. 784. What is the difference between the highest and the lowest Number of total applications in China?
Provide a succinct answer. 9.61e+05. What is the difference between the highest and the lowest Number of total applications in Lithuania?
Ensure brevity in your answer.  2218. What is the difference between the highest and the lowest Number of total applications in New Zealand?
Make the answer very short. 3420. 